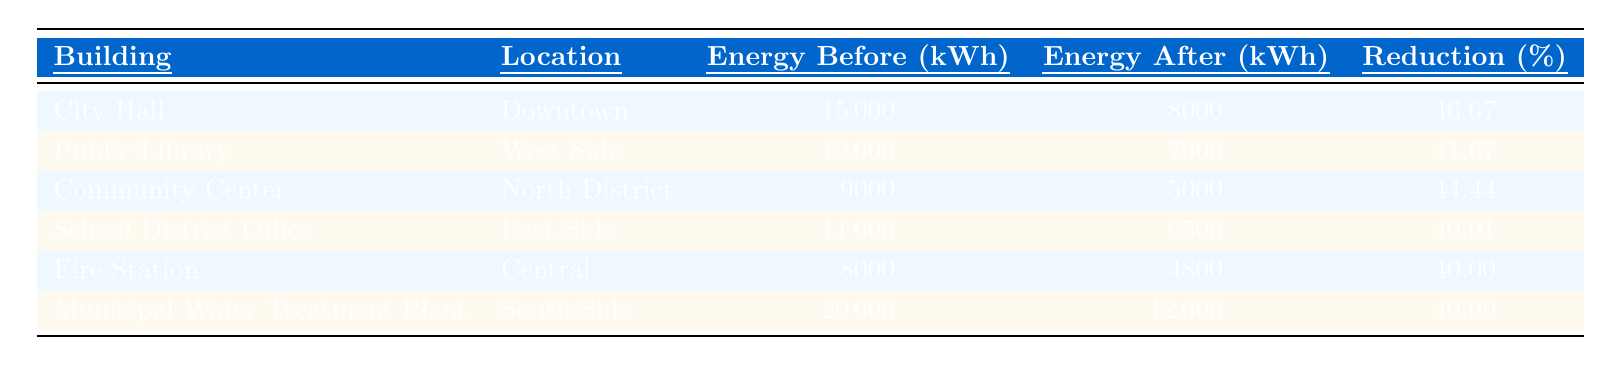What was the energy consumption of the City Hall before installing solar panels? The table lists the energy consumption of City Hall before the installation as 15,000 kWh.
Answer: 15,000 kWh What is the percentage reduction in energy consumption for the Public Library? The table indicates that the percentage reduction for the Public Library is 41.67%.
Answer: 41.67% Which building experienced the highest percentage reduction in energy consumption? By comparing the percentage reductions, City Hall has the highest reduction at 46.67%.
Answer: City Hall What is the average energy consumption after solar panel installation across all buildings? The total energy consumption after installation is 8,000 + 7,000 + 5,000 + 6,500 + 4,800 + 12,000 = 43,300 kWh. There are 6 buildings, so the average is 43,300 / 6 = 7,216.67 kWh.
Answer: 7,216.67 kWh Did the Fire Station reduce its energy consumption by more than 40%? The table shows the Fire Station had a percentage reduction of 40%. This means it did not exceed a 40% reduction.
Answer: No Which location has the lowest energy consumption after installing solar panels? The lowest post-installation consumption is found at the Fire Station with 4,800 kWh.
Answer: Fire Station If we combine the percentage reductions of the Community Center and the Municipal Water Treatment Plant, do they exceed 85%? The reductions are 44.44% (Community Center) and 40.00% (Municipal Water Treatment Plant), which sum to 84.44%, thus they do not exceed 85%.
Answer: No How much total energy was consumed before the solar panel installations across all listed buildings? The summation of energy consumption before installation is 15,000 + 12,000 + 9,000 + 11,000 + 8,000 + 20,000 = 75,000 kWh.
Answer: 75,000 kWh Which building was located in the South Side? The Municipal Water Treatment Plant is listed as being located in the South Side.
Answer: Municipal Water Treatment Plant Did all the buildings exhibit a reduction in energy consumption after solar panel installation? The table does not indicate any non-reducing buildings; all listed percentage reductions are positive.
Answer: Yes 